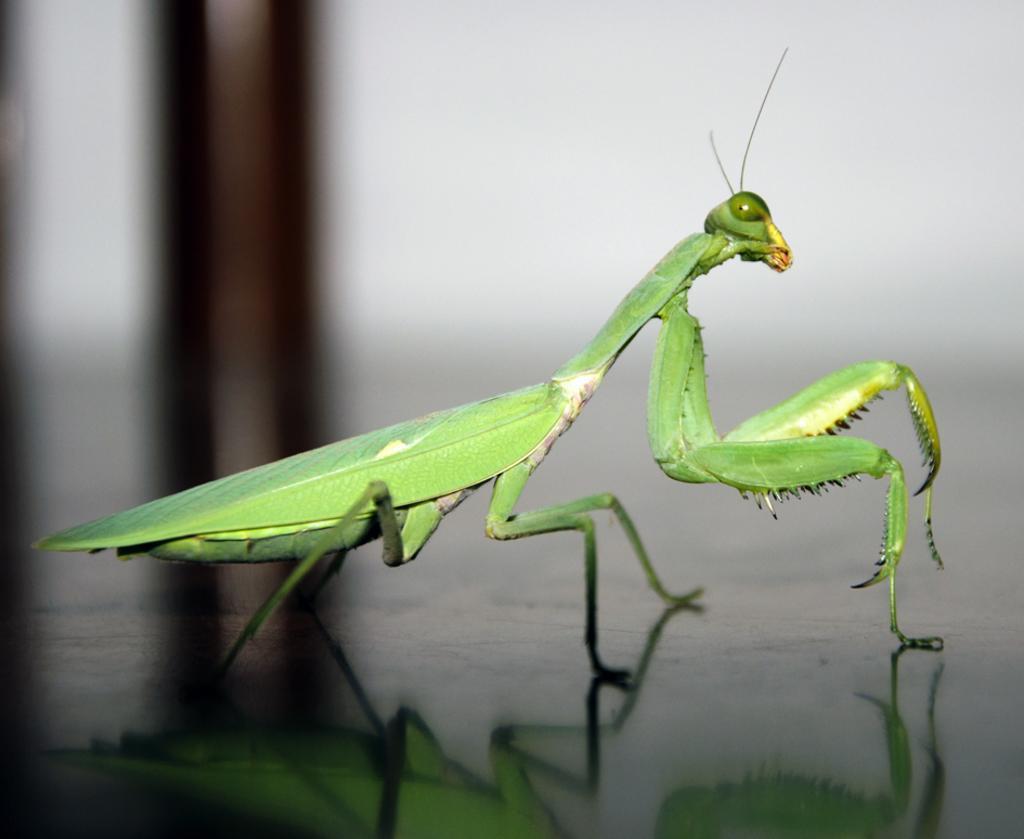Could you give a brief overview of what you see in this image? In this image we can see grasshopper. There is floor. The background is blurry. 